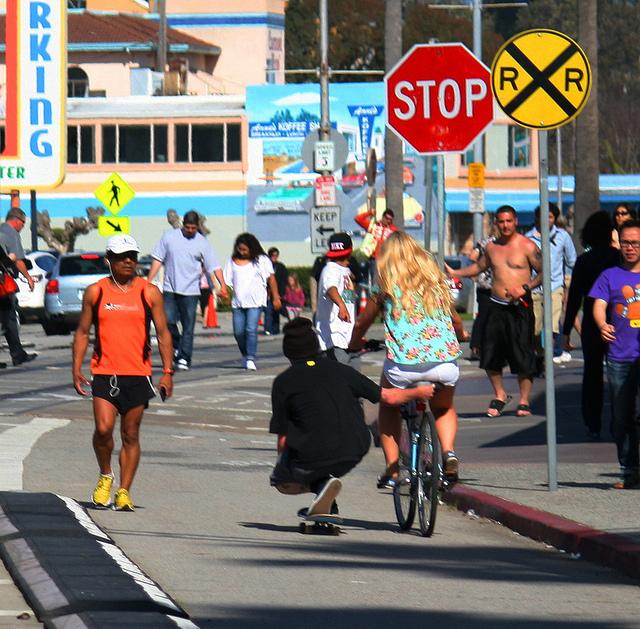Is this picture in the United States?
Give a very brief answer. Yes. Are the people riding bikes?
Quick response, please. Yes. Is this girl riding a bike?
Answer briefly. Yes. What does it say under the stop sign?
Write a very short answer. Nothing. What color shoes is the man in the orange shirt wearing?
Concise answer only. Yellow. How many different kinds of things with wheels are shown?
Write a very short answer. 3. What color shirt is the man closest to the camera wearing?
Short answer required. Orange. 